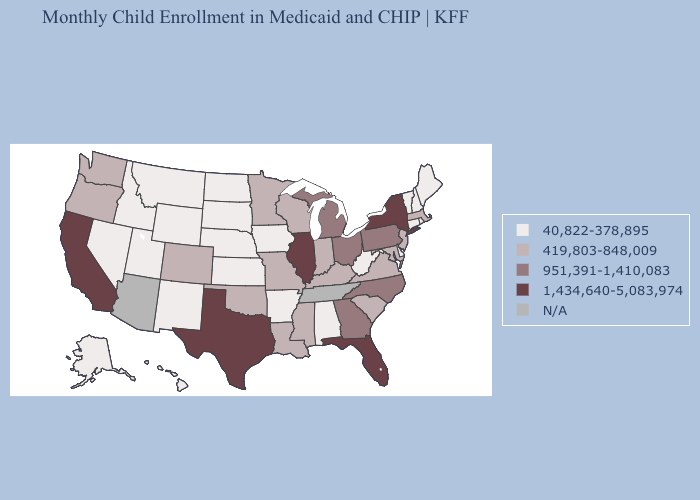What is the value of Tennessee?
Be succinct. N/A. Does Minnesota have the highest value in the USA?
Give a very brief answer. No. Name the states that have a value in the range 419,803-848,009?
Give a very brief answer. Colorado, Indiana, Kentucky, Louisiana, Maryland, Massachusetts, Minnesota, Mississippi, Missouri, New Jersey, Oklahoma, Oregon, South Carolina, Virginia, Washington, Wisconsin. What is the highest value in states that border Indiana?
Write a very short answer. 1,434,640-5,083,974. What is the lowest value in the USA?
Give a very brief answer. 40,822-378,895. How many symbols are there in the legend?
Short answer required. 5. Does the map have missing data?
Give a very brief answer. Yes. How many symbols are there in the legend?
Answer briefly. 5. Does Nevada have the lowest value in the West?
Write a very short answer. Yes. Among the states that border Minnesota , which have the highest value?
Keep it brief. Wisconsin. Among the states that border Colorado , does Kansas have the lowest value?
Be succinct. Yes. Among the states that border Michigan , which have the lowest value?
Give a very brief answer. Indiana, Wisconsin. How many symbols are there in the legend?
Be succinct. 5. 